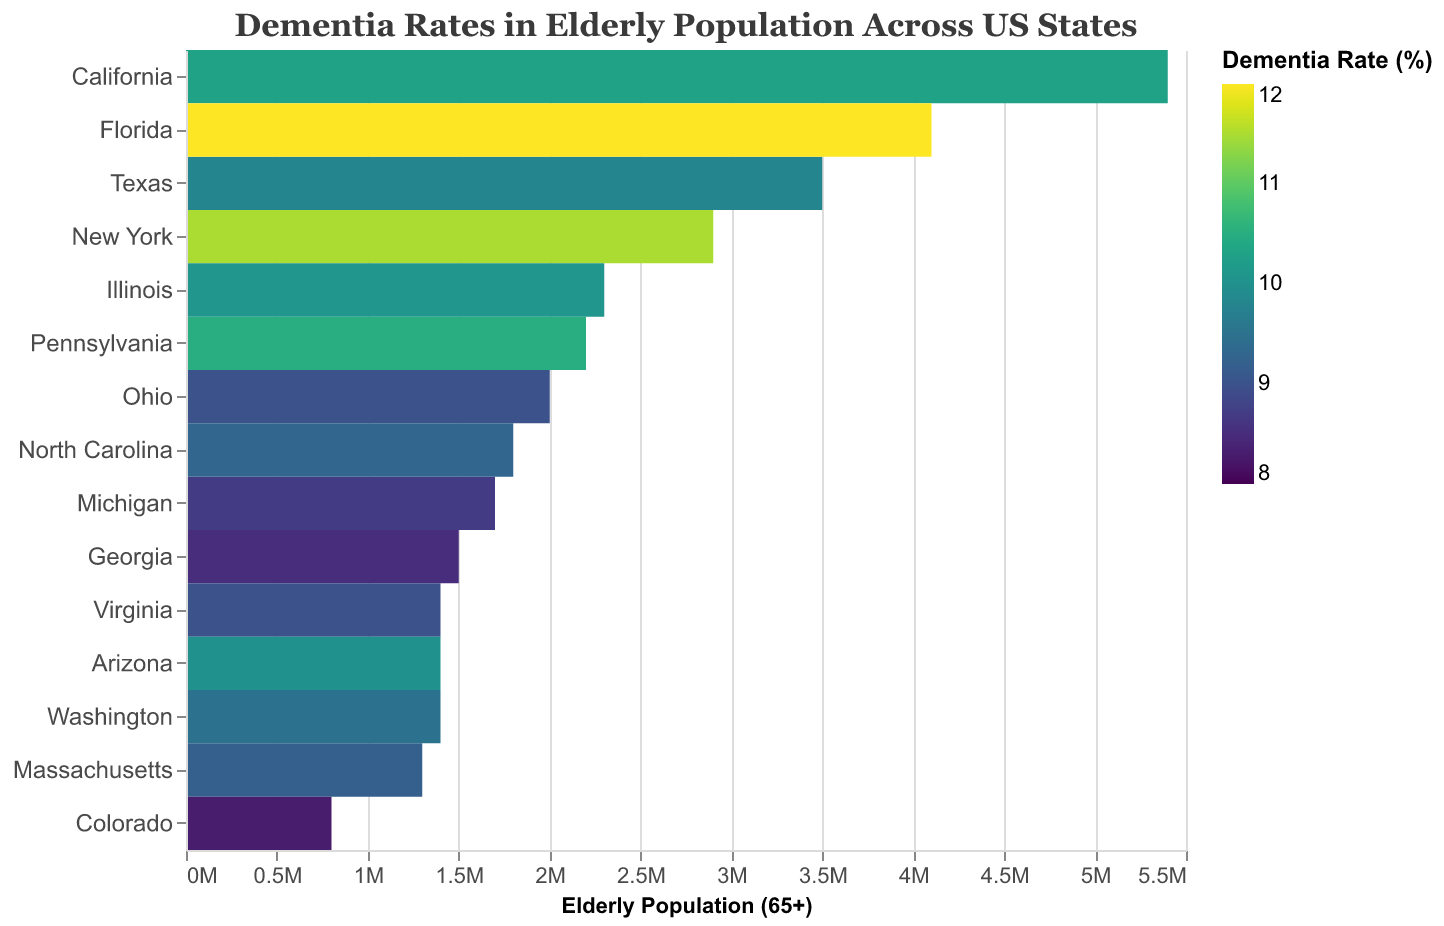Which state has the highest dementia rate? Look at the color scale and find the state with the darkest shade, which signifies the highest dementia rate. Florida has the highest rate at 12.0%.
Answer: Florida What is the elderly population of Texas? Identify Texas on the heatmap and refer to the tooltip or x-axis adjacent to it for the population figure. Texas has an elderly population of 3,500,000.
Answer: 3,500,000 How many states have a dementia rate above 10%? Count the number of states that are colored in shades indicating a dementia rate above 10%, according to the color scale. There are six states: California, Florida, New York, Pennsylvania, Illinois, and Arizona.
Answer: 6 Which state has the lowest dementia rate? Locate the lightest color on the heatmap, which signifies the lowest dementia rate. Colorado has the lowest rate at 8.3%.
Answer: Colorado What is the total number of dementia cases in New York? Find New York on the heatmap and check the tooltip or refer to the figure for the total number of cases. New York has 333,500 dementia cases.
Answer: 333,500 Compare the dementia rates of Michigan and Colorado. Which state has a lower rate? Identify the colors corresponding to Michigan and Colorado and refer to the color scale. Michigan has a dementia rate of 8.7%, while Colorado has a rate of 8.3%. Therefore, Colorado has a lower rate.
Answer: Colorado What's the median dementia rate among all the states listed? List the dementia rates: 8.3, 8.5, 8.7, 9.0, 9.0, 9.2, 9.3, 9.5, 9.8, 10.0, 10.1, 10.3, 10.5, 11.5, 12.0. The median dementia rate is the middle value when sorted: 9.5%.
Answer: 9.5% Is the dementia rate in Ohio above or below the national average of 10%? Find Ohio on the heatmap and check its dementia rate. Ohio has a dementia rate of 9.0%, which is below the national average of 10%.
Answer: Below Which state has a higher elderly population, Washington or Arizona? Compare the elderly population values of Washington and Arizona, found on the x-axis or tooltip. Washington has an elderly population of 1,400,000, and Arizona has an elderly population of 1,400,000. Both states have the same elderly population.
Answer: Both are equal What's the difference in total dementia cases between Virginia and Georgia? Find Virginia and Georgia on the heatmap, note their total dementia cases, and calculate the difference. Virginia has 126,000 cases, and Georgia has 127,500 cases. The difference is 127,500 - 126,000 = 1,500 cases.
Answer: 1,500 